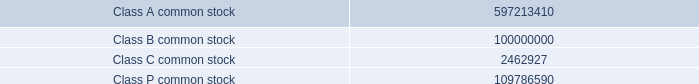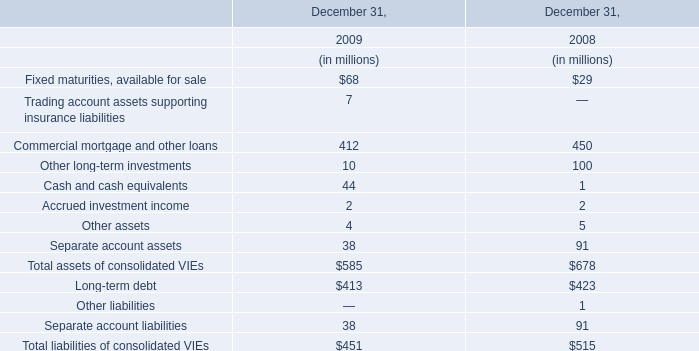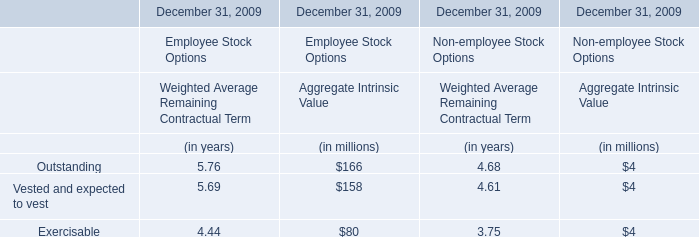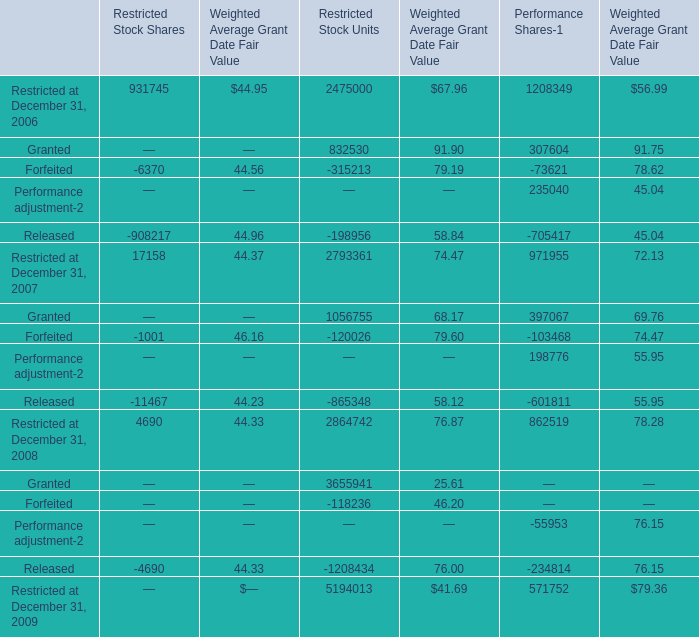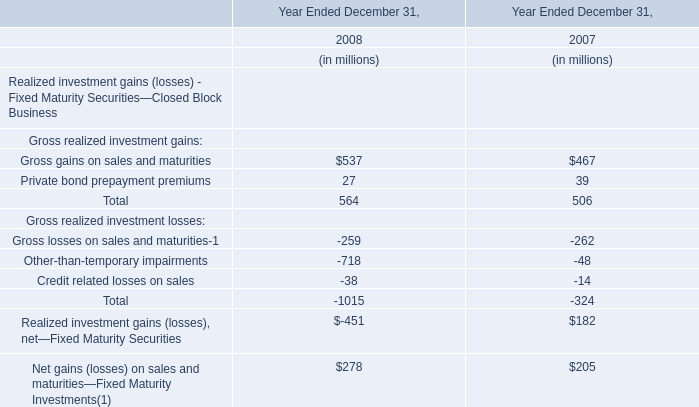What is the sum of Granted of Restricted Stock Units, Class A common stock, and Class C common stock ? 
Computations: ((3655941.0 + 597213410.0) + 2462927.0)
Answer: 603332278.0. 